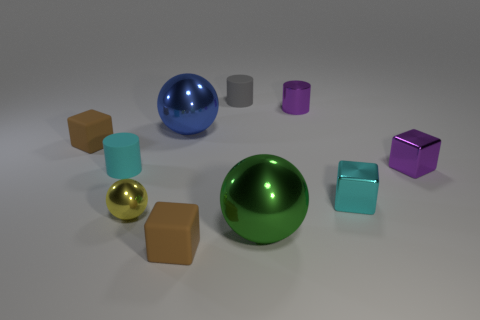What is the size of the shiny cube that is the same color as the tiny metallic cylinder?
Make the answer very short. Small. There is a block that is the same color as the metallic cylinder; what is its material?
Make the answer very short. Metal. What is the shape of the tiny cyan object that is the same material as the blue sphere?
Ensure brevity in your answer.  Cube. Is there anything else that is the same shape as the gray object?
Ensure brevity in your answer.  Yes. What is the shape of the blue metallic thing?
Offer a very short reply. Sphere. Does the brown matte object that is behind the green metallic thing have the same shape as the cyan metal thing?
Your response must be concise. Yes. Is the number of purple cubes that are in front of the green thing greater than the number of blue objects that are on the left side of the tiny cyan shiny object?
Make the answer very short. No. How many other things are the same size as the blue shiny thing?
Make the answer very short. 1. There is a tiny yellow shiny thing; is it the same shape as the brown thing in front of the yellow metallic object?
Offer a terse response. No. How many matte objects are brown balls or purple blocks?
Provide a succinct answer. 0. 